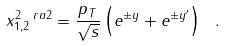<formula> <loc_0><loc_0><loc_500><loc_500>x _ { 1 , 2 } ^ { 2 \ r a 2 } = \frac { p _ { T } } { \sqrt { s } } \left ( e ^ { \pm y } + e ^ { \pm y ^ { \prime } } \right ) \ .</formula> 